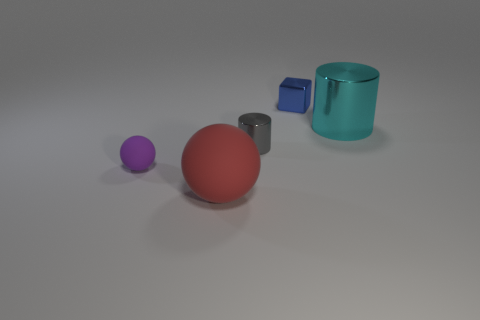Add 1 red metallic cylinders. How many objects exist? 6 Subtract all blocks. How many objects are left? 4 Subtract all large balls. Subtract all large yellow shiny blocks. How many objects are left? 4 Add 3 tiny things. How many tiny things are left? 6 Add 4 blue things. How many blue things exist? 5 Subtract 1 blue cubes. How many objects are left? 4 